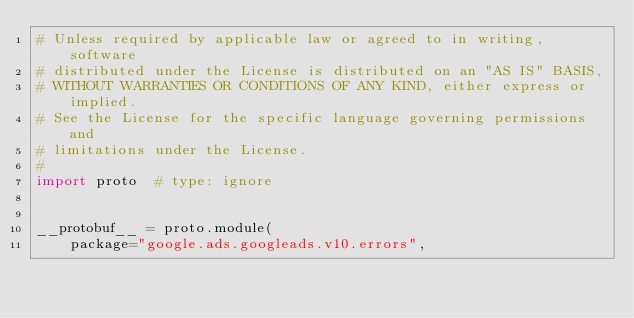<code> <loc_0><loc_0><loc_500><loc_500><_Python_># Unless required by applicable law or agreed to in writing, software
# distributed under the License is distributed on an "AS IS" BASIS,
# WITHOUT WARRANTIES OR CONDITIONS OF ANY KIND, either express or implied.
# See the License for the specific language governing permissions and
# limitations under the License.
#
import proto  # type: ignore


__protobuf__ = proto.module(
    package="google.ads.googleads.v10.errors",</code> 